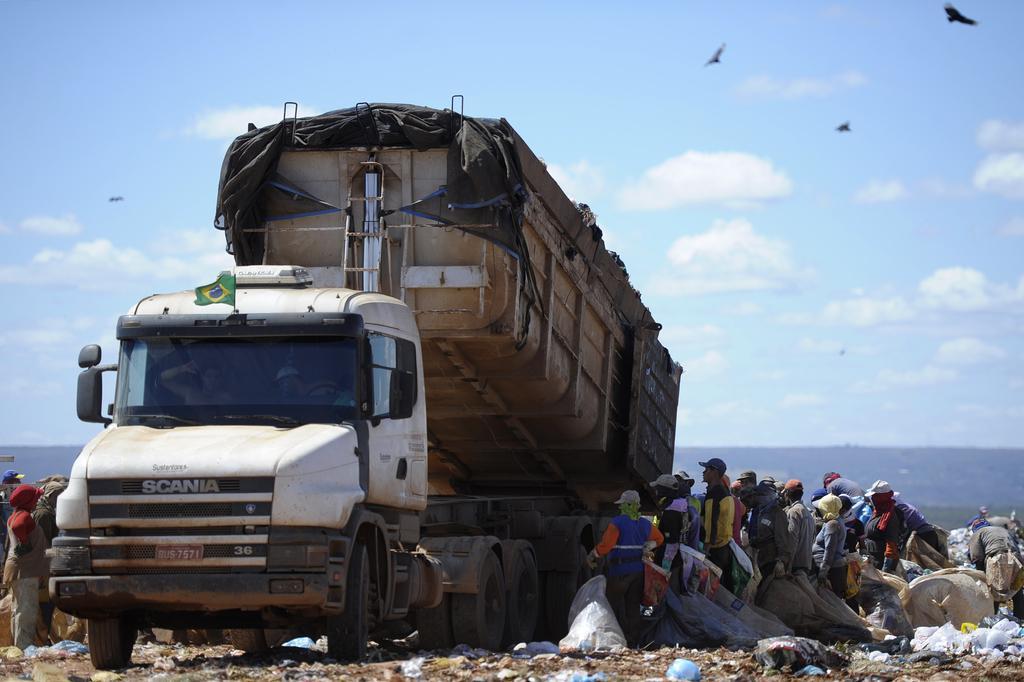In one or two sentences, can you explain what this image depicts? In this picture, we see a truck. Beside that, we see the people are standing and they are holding the garbage bags. At the bottom, we see the garbage. On the left side, we see the people are standing. There are hills in the background. At the top, we see the sky and the clouds. We see the birds flying in the sky. 